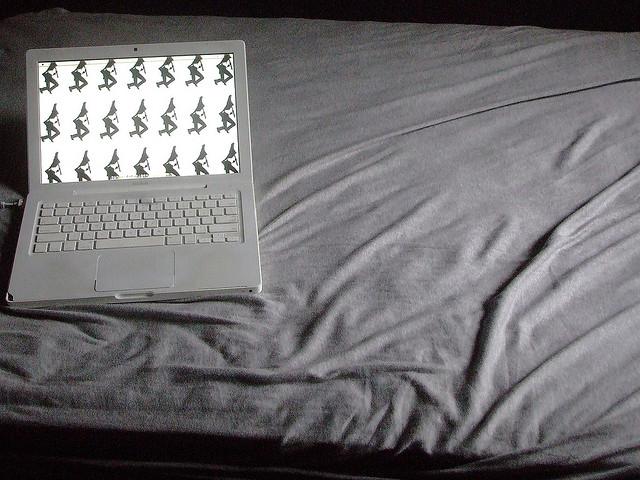Where is the laptop located?
Answer briefly. On bed. Does the bed look slept in?
Be succinct. Yes. What color is the keyboard?
Short answer required. White. What is displayed on the laptop?
Keep it brief. Monogram. 